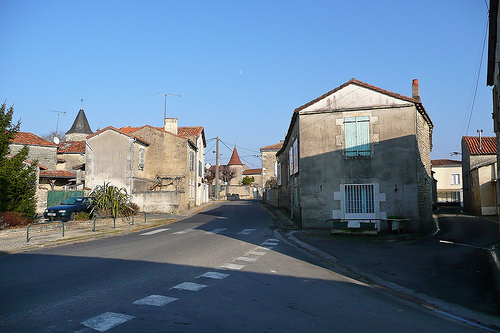<image>
Can you confirm if the shadow is in front of the street? No. The shadow is not in front of the street. The spatial positioning shows a different relationship between these objects. 